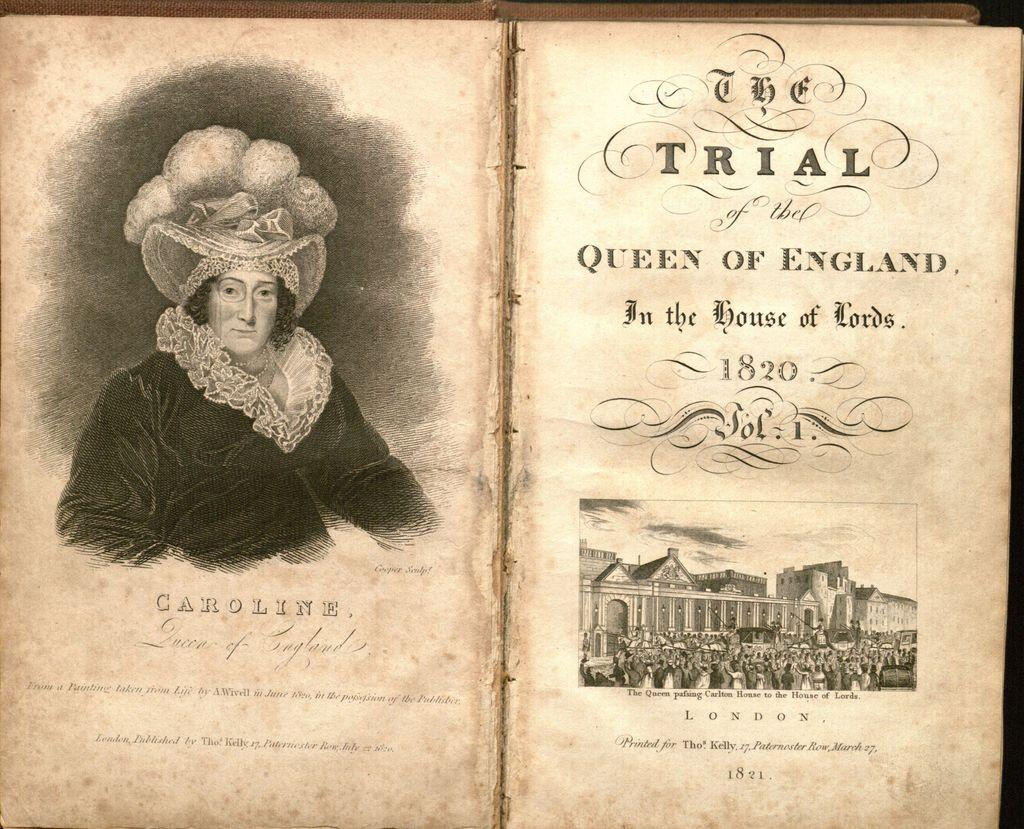<image>
Offer a succinct explanation of the picture presented. A book called The Trial of the Queen of England is opened to its title page. 